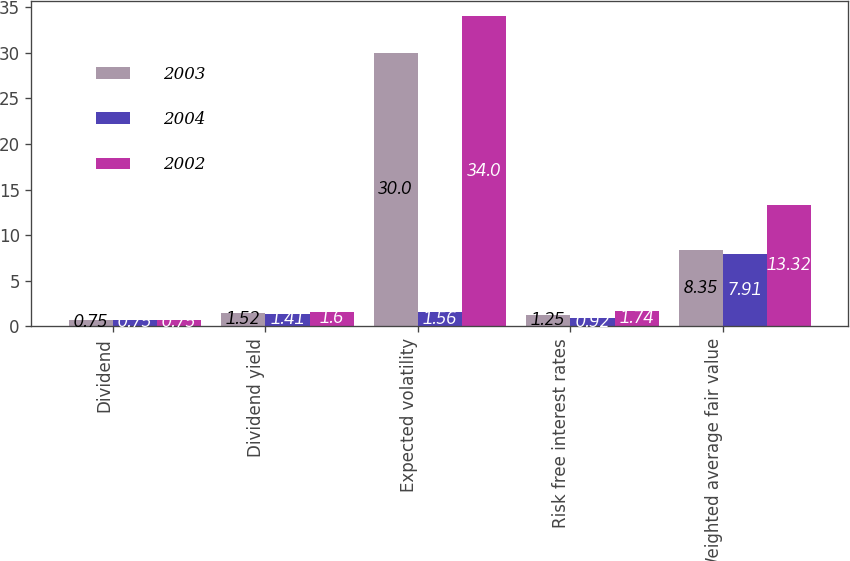Convert chart. <chart><loc_0><loc_0><loc_500><loc_500><stacked_bar_chart><ecel><fcel>Dividend<fcel>Dividend yield<fcel>Expected volatility<fcel>Risk free interest rates<fcel>Weighted average fair value<nl><fcel>2003<fcel>0.75<fcel>1.52<fcel>30<fcel>1.25<fcel>8.35<nl><fcel>2004<fcel>0.75<fcel>1.41<fcel>1.56<fcel>0.92<fcel>7.91<nl><fcel>2002<fcel>0.75<fcel>1.6<fcel>34<fcel>1.74<fcel>13.32<nl></chart> 